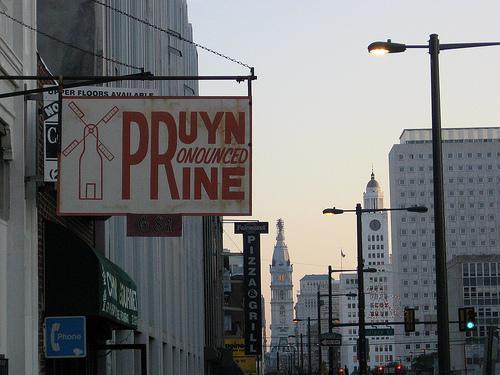How many clock towers are there?
Give a very brief answer. 2. 